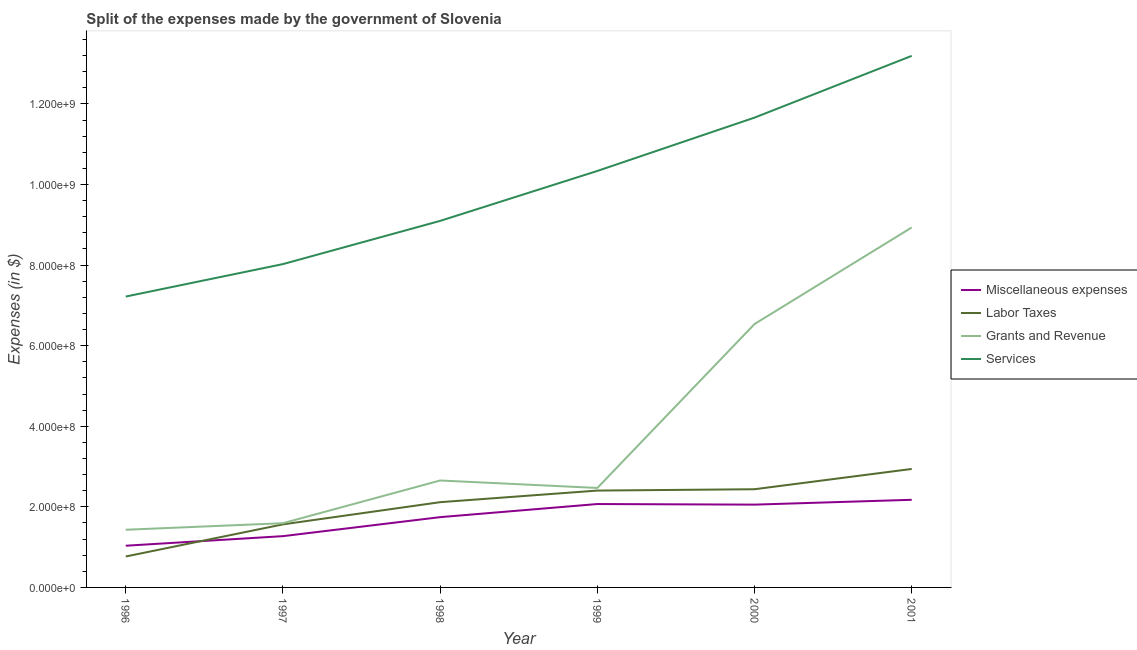What is the amount spent on labor taxes in 2000?
Provide a succinct answer. 2.44e+08. Across all years, what is the maximum amount spent on grants and revenue?
Offer a terse response. 8.93e+08. Across all years, what is the minimum amount spent on miscellaneous expenses?
Offer a very short reply. 1.03e+08. What is the total amount spent on grants and revenue in the graph?
Your answer should be very brief. 2.36e+09. What is the difference between the amount spent on labor taxes in 1996 and that in 1997?
Your answer should be very brief. -7.97e+07. What is the difference between the amount spent on services in 2001 and the amount spent on labor taxes in 1996?
Offer a very short reply. 1.24e+09. What is the average amount spent on miscellaneous expenses per year?
Make the answer very short. 1.73e+08. In the year 2001, what is the difference between the amount spent on labor taxes and amount spent on grants and revenue?
Offer a very short reply. -5.99e+08. In how many years, is the amount spent on services greater than 1160000000 $?
Keep it short and to the point. 2. What is the ratio of the amount spent on grants and revenue in 1996 to that in 2001?
Your answer should be compact. 0.16. Is the difference between the amount spent on grants and revenue in 1996 and 1998 greater than the difference between the amount spent on labor taxes in 1996 and 1998?
Provide a succinct answer. Yes. What is the difference between the highest and the second highest amount spent on miscellaneous expenses?
Offer a very short reply. 1.05e+07. What is the difference between the highest and the lowest amount spent on labor taxes?
Your response must be concise. 2.17e+08. In how many years, is the amount spent on miscellaneous expenses greater than the average amount spent on miscellaneous expenses taken over all years?
Your response must be concise. 4. Is it the case that in every year, the sum of the amount spent on services and amount spent on grants and revenue is greater than the sum of amount spent on labor taxes and amount spent on miscellaneous expenses?
Offer a very short reply. Yes. Is it the case that in every year, the sum of the amount spent on miscellaneous expenses and amount spent on labor taxes is greater than the amount spent on grants and revenue?
Make the answer very short. No. How many lines are there?
Make the answer very short. 4. Does the graph contain any zero values?
Keep it short and to the point. No. How are the legend labels stacked?
Provide a short and direct response. Vertical. What is the title of the graph?
Offer a very short reply. Split of the expenses made by the government of Slovenia. What is the label or title of the X-axis?
Ensure brevity in your answer.  Year. What is the label or title of the Y-axis?
Your response must be concise. Expenses (in $). What is the Expenses (in $) of Miscellaneous expenses in 1996?
Offer a terse response. 1.03e+08. What is the Expenses (in $) in Labor Taxes in 1996?
Give a very brief answer. 7.68e+07. What is the Expenses (in $) of Grants and Revenue in 1996?
Make the answer very short. 1.43e+08. What is the Expenses (in $) in Services in 1996?
Your response must be concise. 7.22e+08. What is the Expenses (in $) in Miscellaneous expenses in 1997?
Give a very brief answer. 1.27e+08. What is the Expenses (in $) of Labor Taxes in 1997?
Your answer should be very brief. 1.56e+08. What is the Expenses (in $) of Grants and Revenue in 1997?
Your answer should be very brief. 1.59e+08. What is the Expenses (in $) of Services in 1997?
Your answer should be compact. 8.02e+08. What is the Expenses (in $) in Miscellaneous expenses in 1998?
Your response must be concise. 1.74e+08. What is the Expenses (in $) of Labor Taxes in 1998?
Your answer should be very brief. 2.12e+08. What is the Expenses (in $) of Grants and Revenue in 1998?
Your response must be concise. 2.65e+08. What is the Expenses (in $) in Services in 1998?
Ensure brevity in your answer.  9.10e+08. What is the Expenses (in $) of Miscellaneous expenses in 1999?
Offer a terse response. 2.07e+08. What is the Expenses (in $) in Labor Taxes in 1999?
Offer a very short reply. 2.40e+08. What is the Expenses (in $) in Grants and Revenue in 1999?
Offer a very short reply. 2.47e+08. What is the Expenses (in $) of Services in 1999?
Give a very brief answer. 1.03e+09. What is the Expenses (in $) in Miscellaneous expenses in 2000?
Provide a succinct answer. 2.05e+08. What is the Expenses (in $) of Labor Taxes in 2000?
Offer a very short reply. 2.44e+08. What is the Expenses (in $) of Grants and Revenue in 2000?
Keep it short and to the point. 6.54e+08. What is the Expenses (in $) of Services in 2000?
Offer a very short reply. 1.17e+09. What is the Expenses (in $) in Miscellaneous expenses in 2001?
Offer a terse response. 2.17e+08. What is the Expenses (in $) in Labor Taxes in 2001?
Your answer should be compact. 2.94e+08. What is the Expenses (in $) in Grants and Revenue in 2001?
Your answer should be very brief. 8.93e+08. What is the Expenses (in $) of Services in 2001?
Your answer should be compact. 1.32e+09. Across all years, what is the maximum Expenses (in $) in Miscellaneous expenses?
Offer a terse response. 2.17e+08. Across all years, what is the maximum Expenses (in $) in Labor Taxes?
Make the answer very short. 2.94e+08. Across all years, what is the maximum Expenses (in $) in Grants and Revenue?
Give a very brief answer. 8.93e+08. Across all years, what is the maximum Expenses (in $) in Services?
Give a very brief answer. 1.32e+09. Across all years, what is the minimum Expenses (in $) of Miscellaneous expenses?
Offer a very short reply. 1.03e+08. Across all years, what is the minimum Expenses (in $) in Labor Taxes?
Offer a terse response. 7.68e+07. Across all years, what is the minimum Expenses (in $) in Grants and Revenue?
Your response must be concise. 1.43e+08. Across all years, what is the minimum Expenses (in $) of Services?
Provide a short and direct response. 7.22e+08. What is the total Expenses (in $) of Miscellaneous expenses in the graph?
Provide a short and direct response. 1.04e+09. What is the total Expenses (in $) in Labor Taxes in the graph?
Provide a short and direct response. 1.22e+09. What is the total Expenses (in $) in Grants and Revenue in the graph?
Your response must be concise. 2.36e+09. What is the total Expenses (in $) of Services in the graph?
Offer a terse response. 5.95e+09. What is the difference between the Expenses (in $) in Miscellaneous expenses in 1996 and that in 1997?
Keep it short and to the point. -2.38e+07. What is the difference between the Expenses (in $) in Labor Taxes in 1996 and that in 1997?
Ensure brevity in your answer.  -7.97e+07. What is the difference between the Expenses (in $) in Grants and Revenue in 1996 and that in 1997?
Give a very brief answer. -1.63e+07. What is the difference between the Expenses (in $) of Services in 1996 and that in 1997?
Offer a terse response. -8.05e+07. What is the difference between the Expenses (in $) in Miscellaneous expenses in 1996 and that in 1998?
Keep it short and to the point. -7.09e+07. What is the difference between the Expenses (in $) in Labor Taxes in 1996 and that in 1998?
Give a very brief answer. -1.35e+08. What is the difference between the Expenses (in $) in Grants and Revenue in 1996 and that in 1998?
Ensure brevity in your answer.  -1.22e+08. What is the difference between the Expenses (in $) in Services in 1996 and that in 1998?
Offer a terse response. -1.88e+08. What is the difference between the Expenses (in $) of Miscellaneous expenses in 1996 and that in 1999?
Give a very brief answer. -1.03e+08. What is the difference between the Expenses (in $) in Labor Taxes in 1996 and that in 1999?
Offer a terse response. -1.64e+08. What is the difference between the Expenses (in $) in Grants and Revenue in 1996 and that in 1999?
Offer a terse response. -1.04e+08. What is the difference between the Expenses (in $) in Services in 1996 and that in 1999?
Your answer should be compact. -3.12e+08. What is the difference between the Expenses (in $) of Miscellaneous expenses in 1996 and that in 2000?
Your answer should be compact. -1.02e+08. What is the difference between the Expenses (in $) of Labor Taxes in 1996 and that in 2000?
Your answer should be very brief. -1.67e+08. What is the difference between the Expenses (in $) of Grants and Revenue in 1996 and that in 2000?
Offer a terse response. -5.11e+08. What is the difference between the Expenses (in $) in Services in 1996 and that in 2000?
Offer a very short reply. -4.44e+08. What is the difference between the Expenses (in $) of Miscellaneous expenses in 1996 and that in 2001?
Ensure brevity in your answer.  -1.14e+08. What is the difference between the Expenses (in $) of Labor Taxes in 1996 and that in 2001?
Make the answer very short. -2.17e+08. What is the difference between the Expenses (in $) of Grants and Revenue in 1996 and that in 2001?
Your response must be concise. -7.50e+08. What is the difference between the Expenses (in $) in Services in 1996 and that in 2001?
Ensure brevity in your answer.  -5.97e+08. What is the difference between the Expenses (in $) in Miscellaneous expenses in 1997 and that in 1998?
Provide a short and direct response. -4.72e+07. What is the difference between the Expenses (in $) in Labor Taxes in 1997 and that in 1998?
Make the answer very short. -5.51e+07. What is the difference between the Expenses (in $) in Grants and Revenue in 1997 and that in 1998?
Your answer should be compact. -1.06e+08. What is the difference between the Expenses (in $) of Services in 1997 and that in 1998?
Give a very brief answer. -1.07e+08. What is the difference between the Expenses (in $) in Miscellaneous expenses in 1997 and that in 1999?
Provide a short and direct response. -7.97e+07. What is the difference between the Expenses (in $) of Labor Taxes in 1997 and that in 1999?
Offer a very short reply. -8.39e+07. What is the difference between the Expenses (in $) in Grants and Revenue in 1997 and that in 1999?
Your answer should be compact. -8.75e+07. What is the difference between the Expenses (in $) of Services in 1997 and that in 1999?
Give a very brief answer. -2.31e+08. What is the difference between the Expenses (in $) of Miscellaneous expenses in 1997 and that in 2000?
Give a very brief answer. -7.82e+07. What is the difference between the Expenses (in $) in Labor Taxes in 1997 and that in 2000?
Ensure brevity in your answer.  -8.72e+07. What is the difference between the Expenses (in $) of Grants and Revenue in 1997 and that in 2000?
Provide a succinct answer. -4.94e+08. What is the difference between the Expenses (in $) of Services in 1997 and that in 2000?
Give a very brief answer. -3.64e+08. What is the difference between the Expenses (in $) of Miscellaneous expenses in 1997 and that in 2001?
Your answer should be compact. -9.02e+07. What is the difference between the Expenses (in $) of Labor Taxes in 1997 and that in 2001?
Keep it short and to the point. -1.38e+08. What is the difference between the Expenses (in $) of Grants and Revenue in 1997 and that in 2001?
Offer a very short reply. -7.34e+08. What is the difference between the Expenses (in $) in Services in 1997 and that in 2001?
Keep it short and to the point. -5.17e+08. What is the difference between the Expenses (in $) in Miscellaneous expenses in 1998 and that in 1999?
Offer a terse response. -3.25e+07. What is the difference between the Expenses (in $) of Labor Taxes in 1998 and that in 1999?
Your answer should be very brief. -2.88e+07. What is the difference between the Expenses (in $) of Grants and Revenue in 1998 and that in 1999?
Your answer should be very brief. 1.85e+07. What is the difference between the Expenses (in $) in Services in 1998 and that in 1999?
Make the answer very short. -1.24e+08. What is the difference between the Expenses (in $) of Miscellaneous expenses in 1998 and that in 2000?
Your response must be concise. -3.11e+07. What is the difference between the Expenses (in $) in Labor Taxes in 1998 and that in 2000?
Offer a terse response. -3.21e+07. What is the difference between the Expenses (in $) in Grants and Revenue in 1998 and that in 2000?
Make the answer very short. -3.88e+08. What is the difference between the Expenses (in $) of Services in 1998 and that in 2000?
Ensure brevity in your answer.  -2.56e+08. What is the difference between the Expenses (in $) in Miscellaneous expenses in 1998 and that in 2001?
Your response must be concise. -4.31e+07. What is the difference between the Expenses (in $) in Labor Taxes in 1998 and that in 2001?
Your response must be concise. -8.25e+07. What is the difference between the Expenses (in $) in Grants and Revenue in 1998 and that in 2001?
Your answer should be compact. -6.28e+08. What is the difference between the Expenses (in $) in Services in 1998 and that in 2001?
Provide a succinct answer. -4.10e+08. What is the difference between the Expenses (in $) in Miscellaneous expenses in 1999 and that in 2000?
Ensure brevity in your answer.  1.48e+06. What is the difference between the Expenses (in $) of Labor Taxes in 1999 and that in 2000?
Your answer should be very brief. -3.35e+06. What is the difference between the Expenses (in $) in Grants and Revenue in 1999 and that in 2000?
Make the answer very short. -4.07e+08. What is the difference between the Expenses (in $) in Services in 1999 and that in 2000?
Keep it short and to the point. -1.32e+08. What is the difference between the Expenses (in $) of Miscellaneous expenses in 1999 and that in 2001?
Ensure brevity in your answer.  -1.05e+07. What is the difference between the Expenses (in $) in Labor Taxes in 1999 and that in 2001?
Give a very brief answer. -5.37e+07. What is the difference between the Expenses (in $) in Grants and Revenue in 1999 and that in 2001?
Give a very brief answer. -6.46e+08. What is the difference between the Expenses (in $) of Services in 1999 and that in 2001?
Ensure brevity in your answer.  -2.86e+08. What is the difference between the Expenses (in $) in Miscellaneous expenses in 2000 and that in 2001?
Make the answer very short. -1.20e+07. What is the difference between the Expenses (in $) in Labor Taxes in 2000 and that in 2001?
Ensure brevity in your answer.  -5.04e+07. What is the difference between the Expenses (in $) of Grants and Revenue in 2000 and that in 2001?
Your response must be concise. -2.40e+08. What is the difference between the Expenses (in $) in Services in 2000 and that in 2001?
Your answer should be compact. -1.53e+08. What is the difference between the Expenses (in $) in Miscellaneous expenses in 1996 and the Expenses (in $) in Labor Taxes in 1997?
Provide a short and direct response. -5.30e+07. What is the difference between the Expenses (in $) in Miscellaneous expenses in 1996 and the Expenses (in $) in Grants and Revenue in 1997?
Your answer should be compact. -5.59e+07. What is the difference between the Expenses (in $) in Miscellaneous expenses in 1996 and the Expenses (in $) in Services in 1997?
Ensure brevity in your answer.  -6.99e+08. What is the difference between the Expenses (in $) of Labor Taxes in 1996 and the Expenses (in $) of Grants and Revenue in 1997?
Your answer should be compact. -8.26e+07. What is the difference between the Expenses (in $) in Labor Taxes in 1996 and the Expenses (in $) in Services in 1997?
Offer a terse response. -7.26e+08. What is the difference between the Expenses (in $) in Grants and Revenue in 1996 and the Expenses (in $) in Services in 1997?
Provide a succinct answer. -6.59e+08. What is the difference between the Expenses (in $) in Miscellaneous expenses in 1996 and the Expenses (in $) in Labor Taxes in 1998?
Give a very brief answer. -1.08e+08. What is the difference between the Expenses (in $) of Miscellaneous expenses in 1996 and the Expenses (in $) of Grants and Revenue in 1998?
Keep it short and to the point. -1.62e+08. What is the difference between the Expenses (in $) of Miscellaneous expenses in 1996 and the Expenses (in $) of Services in 1998?
Your answer should be compact. -8.06e+08. What is the difference between the Expenses (in $) of Labor Taxes in 1996 and the Expenses (in $) of Grants and Revenue in 1998?
Give a very brief answer. -1.89e+08. What is the difference between the Expenses (in $) in Labor Taxes in 1996 and the Expenses (in $) in Services in 1998?
Provide a short and direct response. -8.33e+08. What is the difference between the Expenses (in $) of Grants and Revenue in 1996 and the Expenses (in $) of Services in 1998?
Your answer should be compact. -7.67e+08. What is the difference between the Expenses (in $) of Miscellaneous expenses in 1996 and the Expenses (in $) of Labor Taxes in 1999?
Ensure brevity in your answer.  -1.37e+08. What is the difference between the Expenses (in $) of Miscellaneous expenses in 1996 and the Expenses (in $) of Grants and Revenue in 1999?
Your answer should be compact. -1.43e+08. What is the difference between the Expenses (in $) in Miscellaneous expenses in 1996 and the Expenses (in $) in Services in 1999?
Your response must be concise. -9.30e+08. What is the difference between the Expenses (in $) of Labor Taxes in 1996 and the Expenses (in $) of Grants and Revenue in 1999?
Your answer should be compact. -1.70e+08. What is the difference between the Expenses (in $) in Labor Taxes in 1996 and the Expenses (in $) in Services in 1999?
Offer a terse response. -9.57e+08. What is the difference between the Expenses (in $) in Grants and Revenue in 1996 and the Expenses (in $) in Services in 1999?
Offer a very short reply. -8.91e+08. What is the difference between the Expenses (in $) of Miscellaneous expenses in 1996 and the Expenses (in $) of Labor Taxes in 2000?
Offer a very short reply. -1.40e+08. What is the difference between the Expenses (in $) in Miscellaneous expenses in 1996 and the Expenses (in $) in Grants and Revenue in 2000?
Offer a very short reply. -5.50e+08. What is the difference between the Expenses (in $) of Miscellaneous expenses in 1996 and the Expenses (in $) of Services in 2000?
Give a very brief answer. -1.06e+09. What is the difference between the Expenses (in $) in Labor Taxes in 1996 and the Expenses (in $) in Grants and Revenue in 2000?
Offer a terse response. -5.77e+08. What is the difference between the Expenses (in $) of Labor Taxes in 1996 and the Expenses (in $) of Services in 2000?
Offer a terse response. -1.09e+09. What is the difference between the Expenses (in $) in Grants and Revenue in 1996 and the Expenses (in $) in Services in 2000?
Provide a short and direct response. -1.02e+09. What is the difference between the Expenses (in $) in Miscellaneous expenses in 1996 and the Expenses (in $) in Labor Taxes in 2001?
Your answer should be compact. -1.91e+08. What is the difference between the Expenses (in $) in Miscellaneous expenses in 1996 and the Expenses (in $) in Grants and Revenue in 2001?
Provide a short and direct response. -7.90e+08. What is the difference between the Expenses (in $) of Miscellaneous expenses in 1996 and the Expenses (in $) of Services in 2001?
Your response must be concise. -1.22e+09. What is the difference between the Expenses (in $) in Labor Taxes in 1996 and the Expenses (in $) in Grants and Revenue in 2001?
Ensure brevity in your answer.  -8.17e+08. What is the difference between the Expenses (in $) in Labor Taxes in 1996 and the Expenses (in $) in Services in 2001?
Offer a terse response. -1.24e+09. What is the difference between the Expenses (in $) of Grants and Revenue in 1996 and the Expenses (in $) of Services in 2001?
Your answer should be compact. -1.18e+09. What is the difference between the Expenses (in $) of Miscellaneous expenses in 1997 and the Expenses (in $) of Labor Taxes in 1998?
Give a very brief answer. -8.43e+07. What is the difference between the Expenses (in $) in Miscellaneous expenses in 1997 and the Expenses (in $) in Grants and Revenue in 1998?
Your answer should be compact. -1.38e+08. What is the difference between the Expenses (in $) in Miscellaneous expenses in 1997 and the Expenses (in $) in Services in 1998?
Ensure brevity in your answer.  -7.82e+08. What is the difference between the Expenses (in $) in Labor Taxes in 1997 and the Expenses (in $) in Grants and Revenue in 1998?
Your answer should be compact. -1.09e+08. What is the difference between the Expenses (in $) in Labor Taxes in 1997 and the Expenses (in $) in Services in 1998?
Keep it short and to the point. -7.53e+08. What is the difference between the Expenses (in $) of Grants and Revenue in 1997 and the Expenses (in $) of Services in 1998?
Provide a succinct answer. -7.50e+08. What is the difference between the Expenses (in $) in Miscellaneous expenses in 1997 and the Expenses (in $) in Labor Taxes in 1999?
Your answer should be compact. -1.13e+08. What is the difference between the Expenses (in $) in Miscellaneous expenses in 1997 and the Expenses (in $) in Grants and Revenue in 1999?
Make the answer very short. -1.20e+08. What is the difference between the Expenses (in $) of Miscellaneous expenses in 1997 and the Expenses (in $) of Services in 1999?
Keep it short and to the point. -9.06e+08. What is the difference between the Expenses (in $) of Labor Taxes in 1997 and the Expenses (in $) of Grants and Revenue in 1999?
Keep it short and to the point. -9.04e+07. What is the difference between the Expenses (in $) in Labor Taxes in 1997 and the Expenses (in $) in Services in 1999?
Give a very brief answer. -8.77e+08. What is the difference between the Expenses (in $) of Grants and Revenue in 1997 and the Expenses (in $) of Services in 1999?
Provide a short and direct response. -8.74e+08. What is the difference between the Expenses (in $) in Miscellaneous expenses in 1997 and the Expenses (in $) in Labor Taxes in 2000?
Provide a short and direct response. -1.16e+08. What is the difference between the Expenses (in $) of Miscellaneous expenses in 1997 and the Expenses (in $) of Grants and Revenue in 2000?
Make the answer very short. -5.26e+08. What is the difference between the Expenses (in $) of Miscellaneous expenses in 1997 and the Expenses (in $) of Services in 2000?
Ensure brevity in your answer.  -1.04e+09. What is the difference between the Expenses (in $) of Labor Taxes in 1997 and the Expenses (in $) of Grants and Revenue in 2000?
Provide a succinct answer. -4.97e+08. What is the difference between the Expenses (in $) in Labor Taxes in 1997 and the Expenses (in $) in Services in 2000?
Offer a terse response. -1.01e+09. What is the difference between the Expenses (in $) in Grants and Revenue in 1997 and the Expenses (in $) in Services in 2000?
Your answer should be compact. -1.01e+09. What is the difference between the Expenses (in $) in Miscellaneous expenses in 1997 and the Expenses (in $) in Labor Taxes in 2001?
Make the answer very short. -1.67e+08. What is the difference between the Expenses (in $) of Miscellaneous expenses in 1997 and the Expenses (in $) of Grants and Revenue in 2001?
Ensure brevity in your answer.  -7.66e+08. What is the difference between the Expenses (in $) in Miscellaneous expenses in 1997 and the Expenses (in $) in Services in 2001?
Give a very brief answer. -1.19e+09. What is the difference between the Expenses (in $) in Labor Taxes in 1997 and the Expenses (in $) in Grants and Revenue in 2001?
Provide a succinct answer. -7.37e+08. What is the difference between the Expenses (in $) in Labor Taxes in 1997 and the Expenses (in $) in Services in 2001?
Your answer should be very brief. -1.16e+09. What is the difference between the Expenses (in $) in Grants and Revenue in 1997 and the Expenses (in $) in Services in 2001?
Your response must be concise. -1.16e+09. What is the difference between the Expenses (in $) in Miscellaneous expenses in 1998 and the Expenses (in $) in Labor Taxes in 1999?
Offer a very short reply. -6.59e+07. What is the difference between the Expenses (in $) in Miscellaneous expenses in 1998 and the Expenses (in $) in Grants and Revenue in 1999?
Your answer should be very brief. -7.24e+07. What is the difference between the Expenses (in $) in Miscellaneous expenses in 1998 and the Expenses (in $) in Services in 1999?
Make the answer very short. -8.59e+08. What is the difference between the Expenses (in $) in Labor Taxes in 1998 and the Expenses (in $) in Grants and Revenue in 1999?
Keep it short and to the point. -3.53e+07. What is the difference between the Expenses (in $) of Labor Taxes in 1998 and the Expenses (in $) of Services in 1999?
Your answer should be compact. -8.22e+08. What is the difference between the Expenses (in $) in Grants and Revenue in 1998 and the Expenses (in $) in Services in 1999?
Give a very brief answer. -7.68e+08. What is the difference between the Expenses (in $) in Miscellaneous expenses in 1998 and the Expenses (in $) in Labor Taxes in 2000?
Offer a very short reply. -6.93e+07. What is the difference between the Expenses (in $) of Miscellaneous expenses in 1998 and the Expenses (in $) of Grants and Revenue in 2000?
Your answer should be very brief. -4.79e+08. What is the difference between the Expenses (in $) of Miscellaneous expenses in 1998 and the Expenses (in $) of Services in 2000?
Your answer should be very brief. -9.92e+08. What is the difference between the Expenses (in $) in Labor Taxes in 1998 and the Expenses (in $) in Grants and Revenue in 2000?
Provide a succinct answer. -4.42e+08. What is the difference between the Expenses (in $) in Labor Taxes in 1998 and the Expenses (in $) in Services in 2000?
Your answer should be very brief. -9.54e+08. What is the difference between the Expenses (in $) in Grants and Revenue in 1998 and the Expenses (in $) in Services in 2000?
Your response must be concise. -9.01e+08. What is the difference between the Expenses (in $) in Miscellaneous expenses in 1998 and the Expenses (in $) in Labor Taxes in 2001?
Your answer should be compact. -1.20e+08. What is the difference between the Expenses (in $) of Miscellaneous expenses in 1998 and the Expenses (in $) of Grants and Revenue in 2001?
Offer a terse response. -7.19e+08. What is the difference between the Expenses (in $) of Miscellaneous expenses in 1998 and the Expenses (in $) of Services in 2001?
Keep it short and to the point. -1.14e+09. What is the difference between the Expenses (in $) of Labor Taxes in 1998 and the Expenses (in $) of Grants and Revenue in 2001?
Offer a terse response. -6.82e+08. What is the difference between the Expenses (in $) of Labor Taxes in 1998 and the Expenses (in $) of Services in 2001?
Give a very brief answer. -1.11e+09. What is the difference between the Expenses (in $) in Grants and Revenue in 1998 and the Expenses (in $) in Services in 2001?
Give a very brief answer. -1.05e+09. What is the difference between the Expenses (in $) of Miscellaneous expenses in 1999 and the Expenses (in $) of Labor Taxes in 2000?
Make the answer very short. -3.67e+07. What is the difference between the Expenses (in $) in Miscellaneous expenses in 1999 and the Expenses (in $) in Grants and Revenue in 2000?
Offer a very short reply. -4.47e+08. What is the difference between the Expenses (in $) in Miscellaneous expenses in 1999 and the Expenses (in $) in Services in 2000?
Your answer should be compact. -9.59e+08. What is the difference between the Expenses (in $) in Labor Taxes in 1999 and the Expenses (in $) in Grants and Revenue in 2000?
Offer a terse response. -4.13e+08. What is the difference between the Expenses (in $) in Labor Taxes in 1999 and the Expenses (in $) in Services in 2000?
Your answer should be compact. -9.26e+08. What is the difference between the Expenses (in $) in Grants and Revenue in 1999 and the Expenses (in $) in Services in 2000?
Keep it short and to the point. -9.19e+08. What is the difference between the Expenses (in $) in Miscellaneous expenses in 1999 and the Expenses (in $) in Labor Taxes in 2001?
Provide a short and direct response. -8.71e+07. What is the difference between the Expenses (in $) of Miscellaneous expenses in 1999 and the Expenses (in $) of Grants and Revenue in 2001?
Provide a succinct answer. -6.86e+08. What is the difference between the Expenses (in $) in Miscellaneous expenses in 1999 and the Expenses (in $) in Services in 2001?
Your response must be concise. -1.11e+09. What is the difference between the Expenses (in $) in Labor Taxes in 1999 and the Expenses (in $) in Grants and Revenue in 2001?
Provide a succinct answer. -6.53e+08. What is the difference between the Expenses (in $) of Labor Taxes in 1999 and the Expenses (in $) of Services in 2001?
Provide a succinct answer. -1.08e+09. What is the difference between the Expenses (in $) in Grants and Revenue in 1999 and the Expenses (in $) in Services in 2001?
Offer a very short reply. -1.07e+09. What is the difference between the Expenses (in $) in Miscellaneous expenses in 2000 and the Expenses (in $) in Labor Taxes in 2001?
Your answer should be very brief. -8.86e+07. What is the difference between the Expenses (in $) of Miscellaneous expenses in 2000 and the Expenses (in $) of Grants and Revenue in 2001?
Provide a succinct answer. -6.88e+08. What is the difference between the Expenses (in $) in Miscellaneous expenses in 2000 and the Expenses (in $) in Services in 2001?
Ensure brevity in your answer.  -1.11e+09. What is the difference between the Expenses (in $) of Labor Taxes in 2000 and the Expenses (in $) of Grants and Revenue in 2001?
Provide a short and direct response. -6.50e+08. What is the difference between the Expenses (in $) in Labor Taxes in 2000 and the Expenses (in $) in Services in 2001?
Provide a short and direct response. -1.08e+09. What is the difference between the Expenses (in $) of Grants and Revenue in 2000 and the Expenses (in $) of Services in 2001?
Ensure brevity in your answer.  -6.66e+08. What is the average Expenses (in $) in Miscellaneous expenses per year?
Provide a short and direct response. 1.73e+08. What is the average Expenses (in $) of Labor Taxes per year?
Give a very brief answer. 2.04e+08. What is the average Expenses (in $) of Grants and Revenue per year?
Offer a very short reply. 3.94e+08. What is the average Expenses (in $) in Services per year?
Provide a short and direct response. 9.92e+08. In the year 1996, what is the difference between the Expenses (in $) in Miscellaneous expenses and Expenses (in $) in Labor Taxes?
Ensure brevity in your answer.  2.67e+07. In the year 1996, what is the difference between the Expenses (in $) of Miscellaneous expenses and Expenses (in $) of Grants and Revenue?
Keep it short and to the point. -3.96e+07. In the year 1996, what is the difference between the Expenses (in $) of Miscellaneous expenses and Expenses (in $) of Services?
Keep it short and to the point. -6.18e+08. In the year 1996, what is the difference between the Expenses (in $) in Labor Taxes and Expenses (in $) in Grants and Revenue?
Give a very brief answer. -6.63e+07. In the year 1996, what is the difference between the Expenses (in $) in Labor Taxes and Expenses (in $) in Services?
Provide a short and direct response. -6.45e+08. In the year 1996, what is the difference between the Expenses (in $) in Grants and Revenue and Expenses (in $) in Services?
Your answer should be compact. -5.79e+08. In the year 1997, what is the difference between the Expenses (in $) of Miscellaneous expenses and Expenses (in $) of Labor Taxes?
Give a very brief answer. -2.92e+07. In the year 1997, what is the difference between the Expenses (in $) of Miscellaneous expenses and Expenses (in $) of Grants and Revenue?
Make the answer very short. -3.21e+07. In the year 1997, what is the difference between the Expenses (in $) in Miscellaneous expenses and Expenses (in $) in Services?
Ensure brevity in your answer.  -6.75e+08. In the year 1997, what is the difference between the Expenses (in $) in Labor Taxes and Expenses (in $) in Grants and Revenue?
Your answer should be very brief. -2.92e+06. In the year 1997, what is the difference between the Expenses (in $) in Labor Taxes and Expenses (in $) in Services?
Provide a short and direct response. -6.46e+08. In the year 1997, what is the difference between the Expenses (in $) in Grants and Revenue and Expenses (in $) in Services?
Provide a short and direct response. -6.43e+08. In the year 1998, what is the difference between the Expenses (in $) of Miscellaneous expenses and Expenses (in $) of Labor Taxes?
Provide a short and direct response. -3.71e+07. In the year 1998, what is the difference between the Expenses (in $) in Miscellaneous expenses and Expenses (in $) in Grants and Revenue?
Give a very brief answer. -9.10e+07. In the year 1998, what is the difference between the Expenses (in $) in Miscellaneous expenses and Expenses (in $) in Services?
Offer a terse response. -7.35e+08. In the year 1998, what is the difference between the Expenses (in $) in Labor Taxes and Expenses (in $) in Grants and Revenue?
Offer a terse response. -5.38e+07. In the year 1998, what is the difference between the Expenses (in $) in Labor Taxes and Expenses (in $) in Services?
Ensure brevity in your answer.  -6.98e+08. In the year 1998, what is the difference between the Expenses (in $) of Grants and Revenue and Expenses (in $) of Services?
Provide a succinct answer. -6.44e+08. In the year 1999, what is the difference between the Expenses (in $) of Miscellaneous expenses and Expenses (in $) of Labor Taxes?
Your answer should be compact. -3.34e+07. In the year 1999, what is the difference between the Expenses (in $) of Miscellaneous expenses and Expenses (in $) of Grants and Revenue?
Provide a succinct answer. -3.99e+07. In the year 1999, what is the difference between the Expenses (in $) in Miscellaneous expenses and Expenses (in $) in Services?
Give a very brief answer. -8.27e+08. In the year 1999, what is the difference between the Expenses (in $) of Labor Taxes and Expenses (in $) of Grants and Revenue?
Ensure brevity in your answer.  -6.51e+06. In the year 1999, what is the difference between the Expenses (in $) in Labor Taxes and Expenses (in $) in Services?
Your response must be concise. -7.93e+08. In the year 1999, what is the difference between the Expenses (in $) in Grants and Revenue and Expenses (in $) in Services?
Your answer should be very brief. -7.87e+08. In the year 2000, what is the difference between the Expenses (in $) of Miscellaneous expenses and Expenses (in $) of Labor Taxes?
Give a very brief answer. -3.82e+07. In the year 2000, what is the difference between the Expenses (in $) in Miscellaneous expenses and Expenses (in $) in Grants and Revenue?
Ensure brevity in your answer.  -4.48e+08. In the year 2000, what is the difference between the Expenses (in $) of Miscellaneous expenses and Expenses (in $) of Services?
Your response must be concise. -9.60e+08. In the year 2000, what is the difference between the Expenses (in $) in Labor Taxes and Expenses (in $) in Grants and Revenue?
Give a very brief answer. -4.10e+08. In the year 2000, what is the difference between the Expenses (in $) of Labor Taxes and Expenses (in $) of Services?
Give a very brief answer. -9.22e+08. In the year 2000, what is the difference between the Expenses (in $) of Grants and Revenue and Expenses (in $) of Services?
Give a very brief answer. -5.12e+08. In the year 2001, what is the difference between the Expenses (in $) in Miscellaneous expenses and Expenses (in $) in Labor Taxes?
Give a very brief answer. -7.66e+07. In the year 2001, what is the difference between the Expenses (in $) in Miscellaneous expenses and Expenses (in $) in Grants and Revenue?
Ensure brevity in your answer.  -6.76e+08. In the year 2001, what is the difference between the Expenses (in $) of Miscellaneous expenses and Expenses (in $) of Services?
Offer a terse response. -1.10e+09. In the year 2001, what is the difference between the Expenses (in $) of Labor Taxes and Expenses (in $) of Grants and Revenue?
Give a very brief answer. -5.99e+08. In the year 2001, what is the difference between the Expenses (in $) of Labor Taxes and Expenses (in $) of Services?
Your answer should be very brief. -1.03e+09. In the year 2001, what is the difference between the Expenses (in $) of Grants and Revenue and Expenses (in $) of Services?
Ensure brevity in your answer.  -4.26e+08. What is the ratio of the Expenses (in $) in Miscellaneous expenses in 1996 to that in 1997?
Provide a short and direct response. 0.81. What is the ratio of the Expenses (in $) in Labor Taxes in 1996 to that in 1997?
Offer a very short reply. 0.49. What is the ratio of the Expenses (in $) in Grants and Revenue in 1996 to that in 1997?
Make the answer very short. 0.9. What is the ratio of the Expenses (in $) of Services in 1996 to that in 1997?
Your answer should be compact. 0.9. What is the ratio of the Expenses (in $) in Miscellaneous expenses in 1996 to that in 1998?
Your response must be concise. 0.59. What is the ratio of the Expenses (in $) in Labor Taxes in 1996 to that in 1998?
Offer a very short reply. 0.36. What is the ratio of the Expenses (in $) of Grants and Revenue in 1996 to that in 1998?
Your response must be concise. 0.54. What is the ratio of the Expenses (in $) of Services in 1996 to that in 1998?
Your answer should be compact. 0.79. What is the ratio of the Expenses (in $) in Miscellaneous expenses in 1996 to that in 1999?
Your answer should be very brief. 0.5. What is the ratio of the Expenses (in $) of Labor Taxes in 1996 to that in 1999?
Provide a succinct answer. 0.32. What is the ratio of the Expenses (in $) of Grants and Revenue in 1996 to that in 1999?
Keep it short and to the point. 0.58. What is the ratio of the Expenses (in $) in Services in 1996 to that in 1999?
Your answer should be very brief. 0.7. What is the ratio of the Expenses (in $) in Miscellaneous expenses in 1996 to that in 2000?
Ensure brevity in your answer.  0.5. What is the ratio of the Expenses (in $) in Labor Taxes in 1996 to that in 2000?
Ensure brevity in your answer.  0.32. What is the ratio of the Expenses (in $) in Grants and Revenue in 1996 to that in 2000?
Offer a terse response. 0.22. What is the ratio of the Expenses (in $) in Services in 1996 to that in 2000?
Your response must be concise. 0.62. What is the ratio of the Expenses (in $) in Miscellaneous expenses in 1996 to that in 2001?
Your response must be concise. 0.48. What is the ratio of the Expenses (in $) of Labor Taxes in 1996 to that in 2001?
Ensure brevity in your answer.  0.26. What is the ratio of the Expenses (in $) of Grants and Revenue in 1996 to that in 2001?
Your response must be concise. 0.16. What is the ratio of the Expenses (in $) in Services in 1996 to that in 2001?
Offer a terse response. 0.55. What is the ratio of the Expenses (in $) in Miscellaneous expenses in 1997 to that in 1998?
Provide a short and direct response. 0.73. What is the ratio of the Expenses (in $) of Labor Taxes in 1997 to that in 1998?
Your answer should be very brief. 0.74. What is the ratio of the Expenses (in $) in Grants and Revenue in 1997 to that in 1998?
Your response must be concise. 0.6. What is the ratio of the Expenses (in $) in Services in 1997 to that in 1998?
Make the answer very short. 0.88. What is the ratio of the Expenses (in $) of Miscellaneous expenses in 1997 to that in 1999?
Make the answer very short. 0.61. What is the ratio of the Expenses (in $) of Labor Taxes in 1997 to that in 1999?
Your answer should be compact. 0.65. What is the ratio of the Expenses (in $) in Grants and Revenue in 1997 to that in 1999?
Provide a short and direct response. 0.65. What is the ratio of the Expenses (in $) of Services in 1997 to that in 1999?
Provide a short and direct response. 0.78. What is the ratio of the Expenses (in $) of Miscellaneous expenses in 1997 to that in 2000?
Ensure brevity in your answer.  0.62. What is the ratio of the Expenses (in $) in Labor Taxes in 1997 to that in 2000?
Your answer should be compact. 0.64. What is the ratio of the Expenses (in $) in Grants and Revenue in 1997 to that in 2000?
Ensure brevity in your answer.  0.24. What is the ratio of the Expenses (in $) in Services in 1997 to that in 2000?
Ensure brevity in your answer.  0.69. What is the ratio of the Expenses (in $) of Miscellaneous expenses in 1997 to that in 2001?
Provide a short and direct response. 0.59. What is the ratio of the Expenses (in $) of Labor Taxes in 1997 to that in 2001?
Offer a terse response. 0.53. What is the ratio of the Expenses (in $) of Grants and Revenue in 1997 to that in 2001?
Give a very brief answer. 0.18. What is the ratio of the Expenses (in $) in Services in 1997 to that in 2001?
Make the answer very short. 0.61. What is the ratio of the Expenses (in $) of Miscellaneous expenses in 1998 to that in 1999?
Keep it short and to the point. 0.84. What is the ratio of the Expenses (in $) of Labor Taxes in 1998 to that in 1999?
Ensure brevity in your answer.  0.88. What is the ratio of the Expenses (in $) of Grants and Revenue in 1998 to that in 1999?
Ensure brevity in your answer.  1.08. What is the ratio of the Expenses (in $) of Services in 1998 to that in 1999?
Make the answer very short. 0.88. What is the ratio of the Expenses (in $) in Miscellaneous expenses in 1998 to that in 2000?
Ensure brevity in your answer.  0.85. What is the ratio of the Expenses (in $) in Labor Taxes in 1998 to that in 2000?
Ensure brevity in your answer.  0.87. What is the ratio of the Expenses (in $) in Grants and Revenue in 1998 to that in 2000?
Your answer should be very brief. 0.41. What is the ratio of the Expenses (in $) in Services in 1998 to that in 2000?
Ensure brevity in your answer.  0.78. What is the ratio of the Expenses (in $) of Miscellaneous expenses in 1998 to that in 2001?
Keep it short and to the point. 0.8. What is the ratio of the Expenses (in $) in Labor Taxes in 1998 to that in 2001?
Ensure brevity in your answer.  0.72. What is the ratio of the Expenses (in $) in Grants and Revenue in 1998 to that in 2001?
Your answer should be very brief. 0.3. What is the ratio of the Expenses (in $) of Services in 1998 to that in 2001?
Your answer should be compact. 0.69. What is the ratio of the Expenses (in $) in Labor Taxes in 1999 to that in 2000?
Make the answer very short. 0.99. What is the ratio of the Expenses (in $) of Grants and Revenue in 1999 to that in 2000?
Make the answer very short. 0.38. What is the ratio of the Expenses (in $) of Services in 1999 to that in 2000?
Provide a succinct answer. 0.89. What is the ratio of the Expenses (in $) of Miscellaneous expenses in 1999 to that in 2001?
Provide a short and direct response. 0.95. What is the ratio of the Expenses (in $) of Labor Taxes in 1999 to that in 2001?
Keep it short and to the point. 0.82. What is the ratio of the Expenses (in $) in Grants and Revenue in 1999 to that in 2001?
Your answer should be very brief. 0.28. What is the ratio of the Expenses (in $) in Services in 1999 to that in 2001?
Keep it short and to the point. 0.78. What is the ratio of the Expenses (in $) in Miscellaneous expenses in 2000 to that in 2001?
Provide a short and direct response. 0.94. What is the ratio of the Expenses (in $) of Labor Taxes in 2000 to that in 2001?
Your answer should be very brief. 0.83. What is the ratio of the Expenses (in $) in Grants and Revenue in 2000 to that in 2001?
Your answer should be compact. 0.73. What is the ratio of the Expenses (in $) in Services in 2000 to that in 2001?
Make the answer very short. 0.88. What is the difference between the highest and the second highest Expenses (in $) in Miscellaneous expenses?
Keep it short and to the point. 1.05e+07. What is the difference between the highest and the second highest Expenses (in $) in Labor Taxes?
Keep it short and to the point. 5.04e+07. What is the difference between the highest and the second highest Expenses (in $) of Grants and Revenue?
Make the answer very short. 2.40e+08. What is the difference between the highest and the second highest Expenses (in $) in Services?
Your answer should be very brief. 1.53e+08. What is the difference between the highest and the lowest Expenses (in $) in Miscellaneous expenses?
Provide a short and direct response. 1.14e+08. What is the difference between the highest and the lowest Expenses (in $) of Labor Taxes?
Ensure brevity in your answer.  2.17e+08. What is the difference between the highest and the lowest Expenses (in $) in Grants and Revenue?
Your response must be concise. 7.50e+08. What is the difference between the highest and the lowest Expenses (in $) of Services?
Make the answer very short. 5.97e+08. 